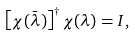<formula> <loc_0><loc_0><loc_500><loc_500>\left [ \chi ( \bar { \lambda } ) \right ] ^ { \dag } \chi ( \lambda ) = I ,</formula> 